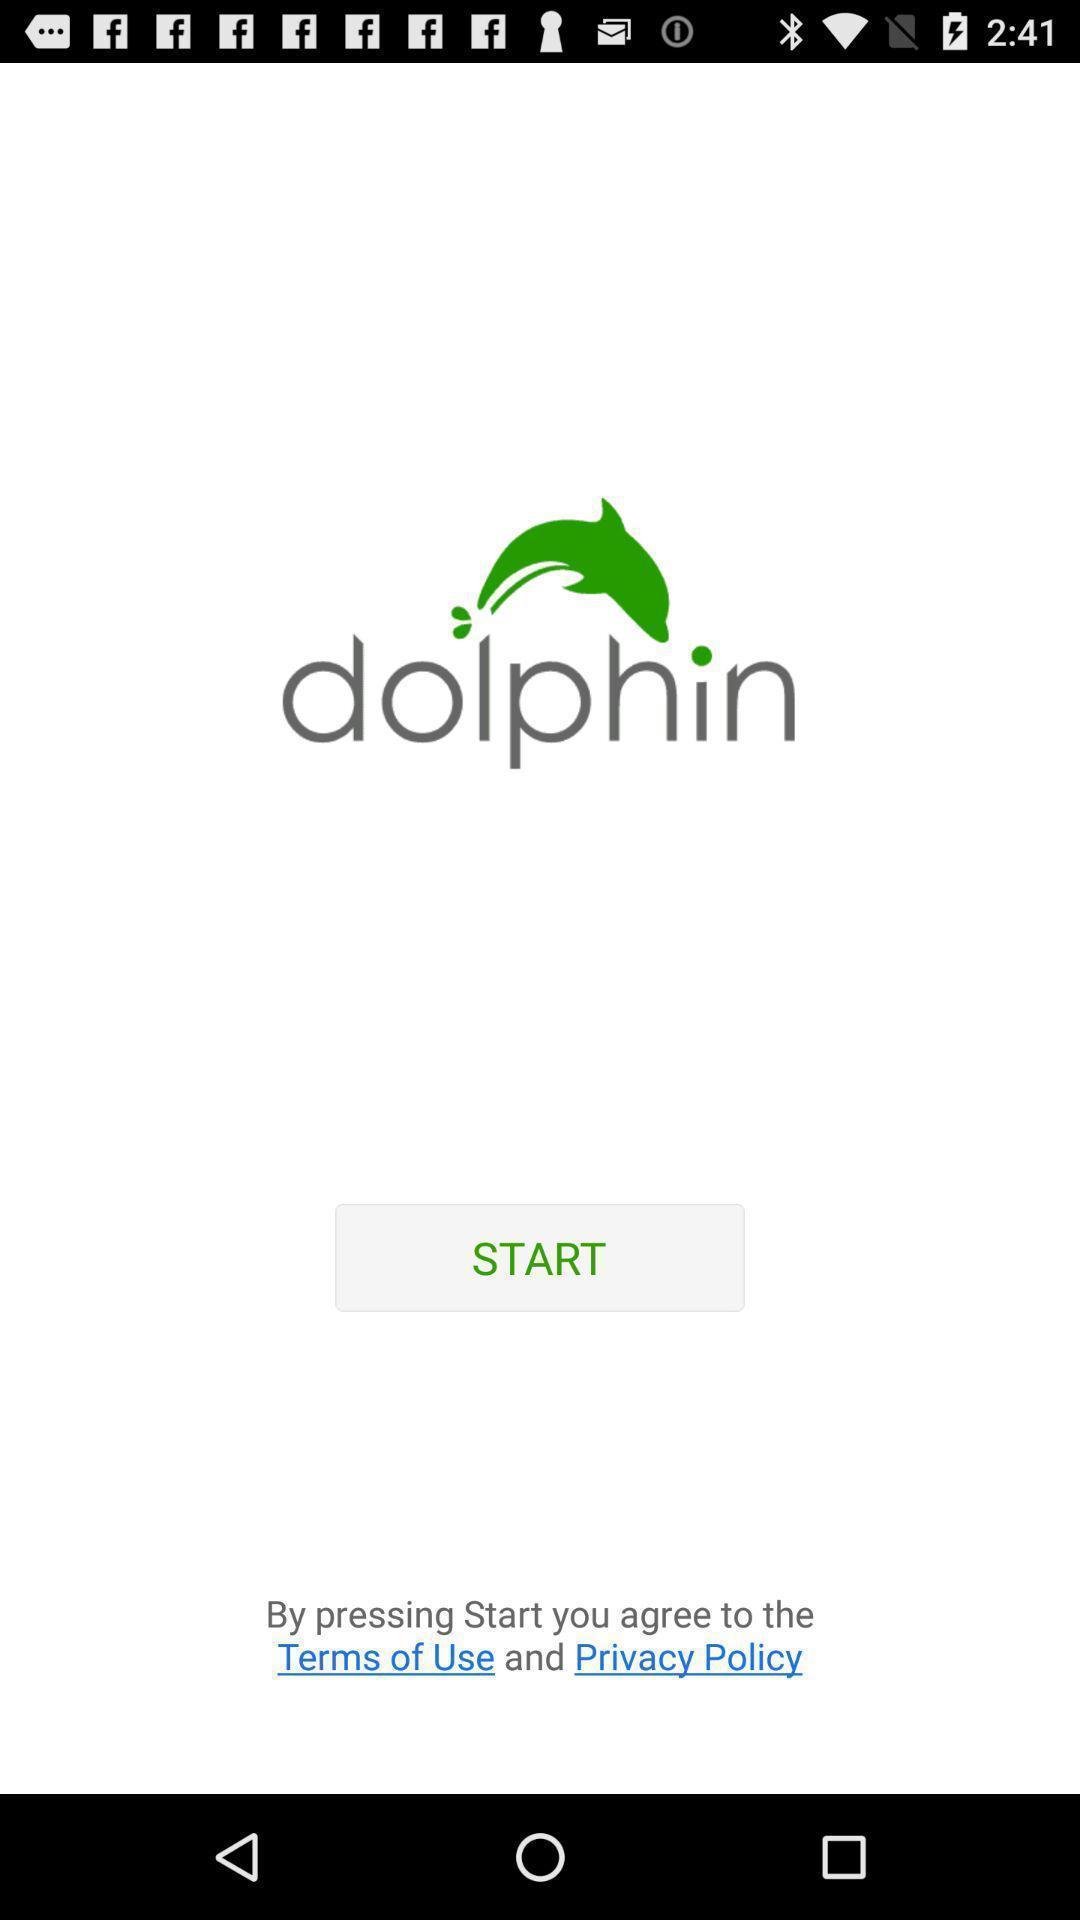What can you discern from this picture? Welcome page of a web browser. 